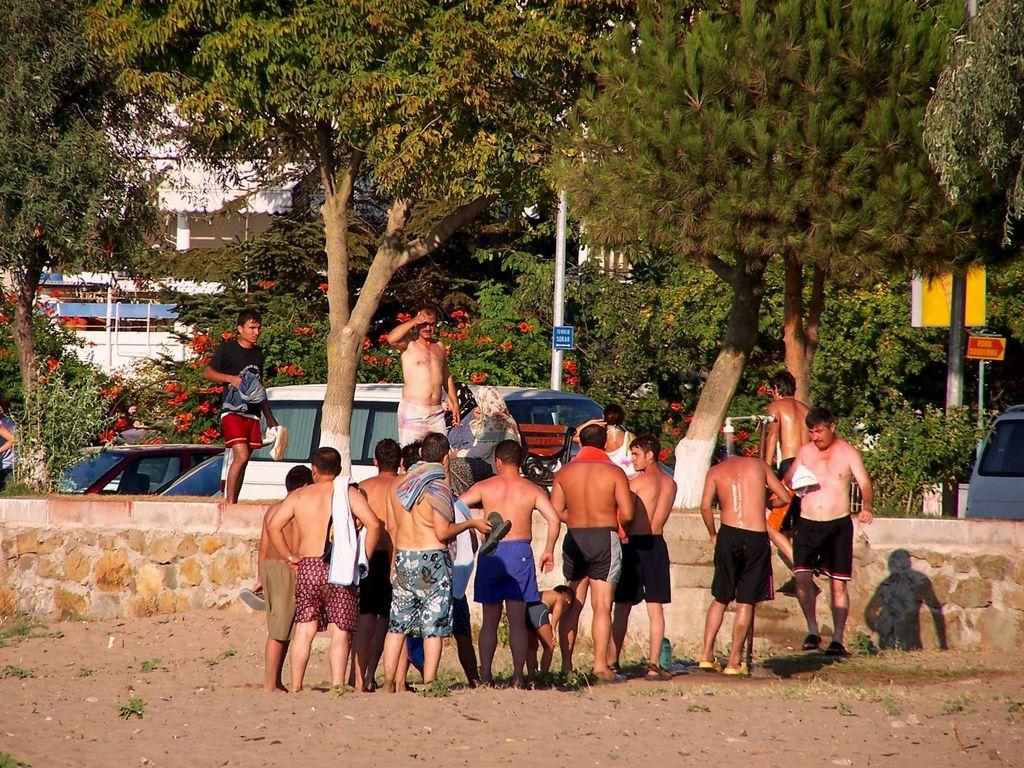What are the people in the image doing? The group of people is standing on the ground. What can be seen in the background of the image? Trees, poles, and boards are visible in the background. Are there any other objects present in the background? Yes, there are other unspecified objects in the background. How many times does the person in the image cry while riding the bike? There is no person riding a bike in the image, nor is there any indication of anyone crying. 